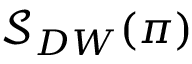Convert formula to latex. <formula><loc_0><loc_0><loc_500><loc_500>\mathcal { S } _ { D W } ( \pi )</formula> 